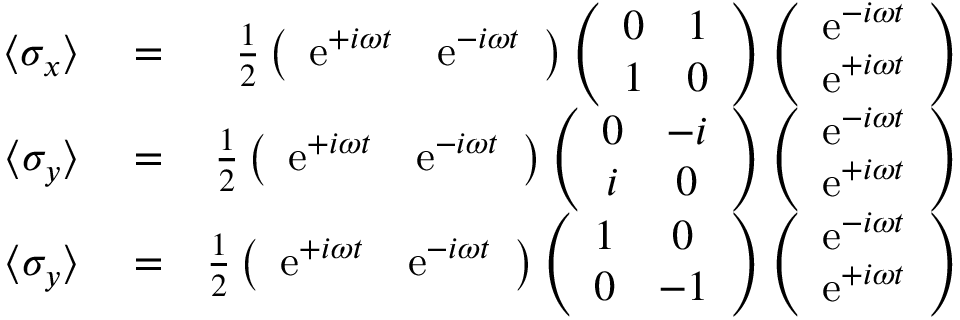Convert formula to latex. <formula><loc_0><loc_0><loc_500><loc_500>\begin{array} { r l r } { \langle \sigma _ { x } \rangle } & = } & { \frac { 1 } { 2 } \left ( \begin{array} { c c } { e ^ { + i \omega t } } & { e ^ { - i \omega t } } \end{array} \right ) \left ( \begin{array} { c c } { 0 } & { 1 } \\ { 1 } & { 0 } \end{array} \right ) \left ( \begin{array} { c } { e ^ { - i \omega t } } \\ { e ^ { + i \omega t } } \end{array} \right ) } \\ { \langle \sigma _ { y } \rangle } & = } & { \frac { 1 } { 2 } \left ( \begin{array} { c c } { e ^ { + i \omega t } } & { e ^ { - i \omega t } } \end{array} \right ) \left ( \begin{array} { c c } { 0 } & { - i } \\ { i } & { 0 } \end{array} \right ) \left ( \begin{array} { c } { e ^ { - i \omega t } } \\ { e ^ { + i \omega t } } \end{array} \right ) } \\ { \langle \sigma _ { y } \rangle } & = } & { \frac { 1 } { 2 } \left ( \begin{array} { c c } { e ^ { + i \omega t } } & { e ^ { - i \omega t } } \end{array} \right ) \left ( \begin{array} { c c } { 1 } & { 0 } \\ { 0 } & { - 1 } \end{array} \right ) \left ( \begin{array} { c } { e ^ { - i \omega t } } \\ { e ^ { + i \omega t } } \end{array} \right ) } \end{array}</formula> 